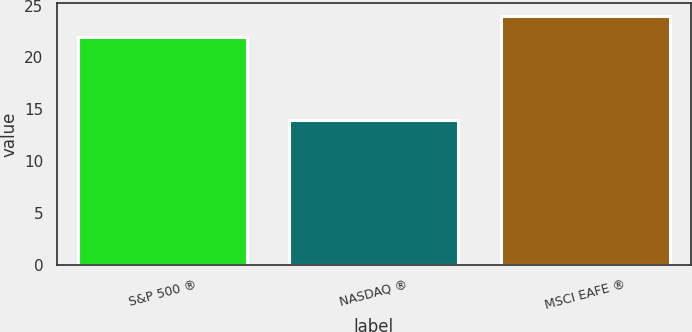<chart> <loc_0><loc_0><loc_500><loc_500><bar_chart><fcel>S&P 500 ®<fcel>NASDAQ ®<fcel>MSCI EAFE ®<nl><fcel>22<fcel>14<fcel>24<nl></chart> 